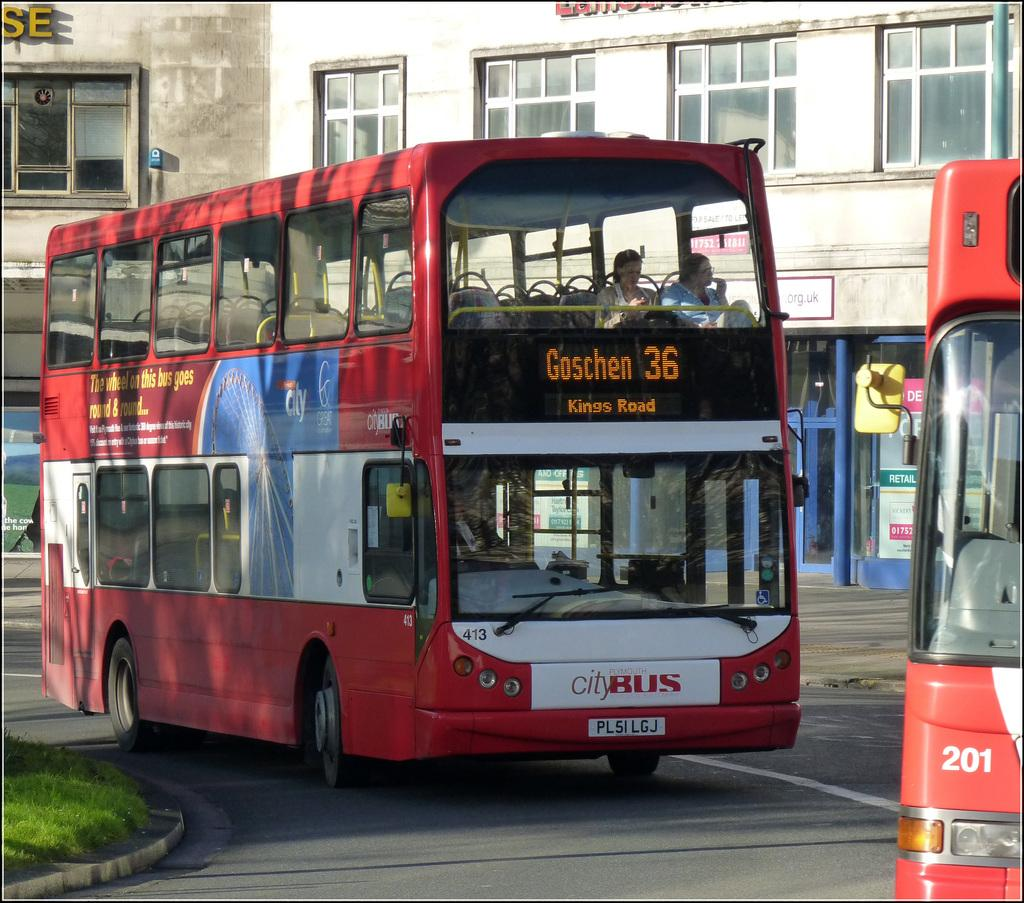<image>
Relay a brief, clear account of the picture shown. An ad on the bus reads, "The wheel on this bus goes round & round..." 